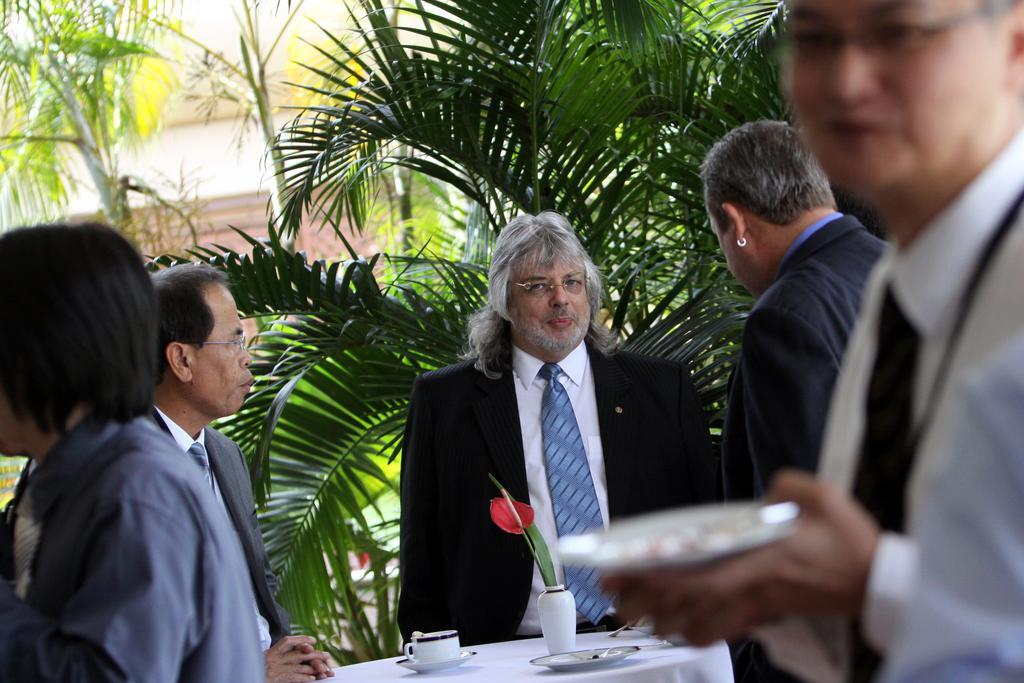Who is the main subject in the image? There is a man standing at the center of the image. What is the man wearing? The man is wearing a suit. Can you describe the other person in the image? There is another man on the right side of the image, and he is holding a plate in his hand. What can be seen in the background of the image? There are trees in the background of the image. How many children are playing with the bait in the image? There are no children or bait present in the image. What type of chair is the man sitting on in the image? The man is not sitting on a chair in the image; he is standing. 